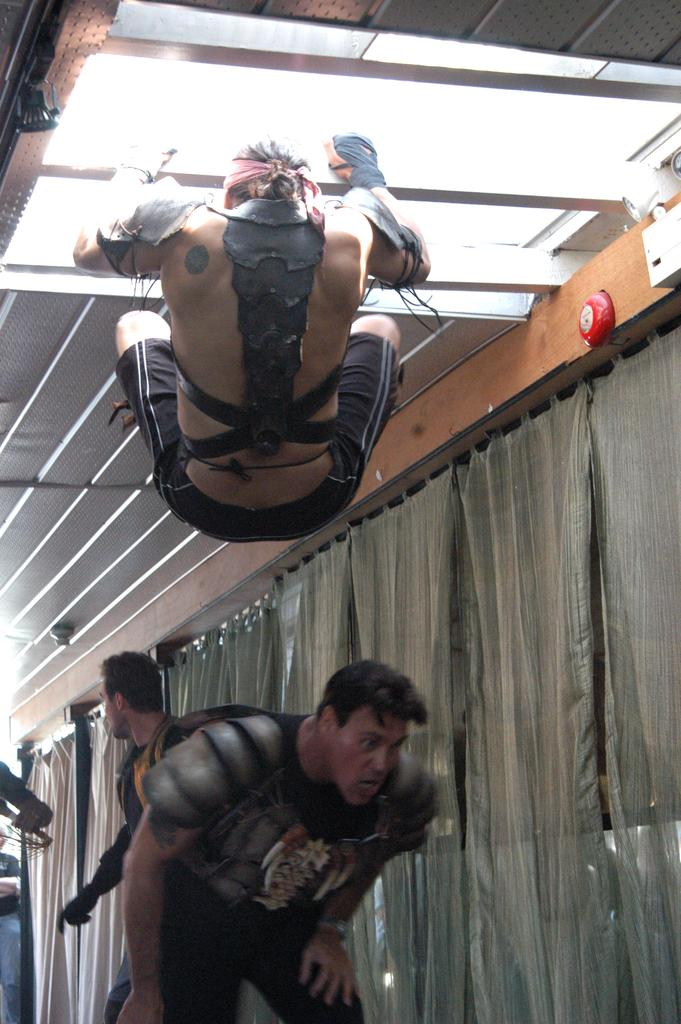How many people are in the image? There are people in the image, but the exact number is not specified. What is one person holding in the image? One person is holding a rod in the image. What type of material are the planks made of? The planks in the image are made of metal. What type of window treatment is present in the image? There are curtains in the image. Can you describe any other objects present in the image? There are other objects present in the image, but their specific nature is not mentioned. How many babies are present in the image? There is no mention of babies in the image, so we cannot determine their presence or number. 